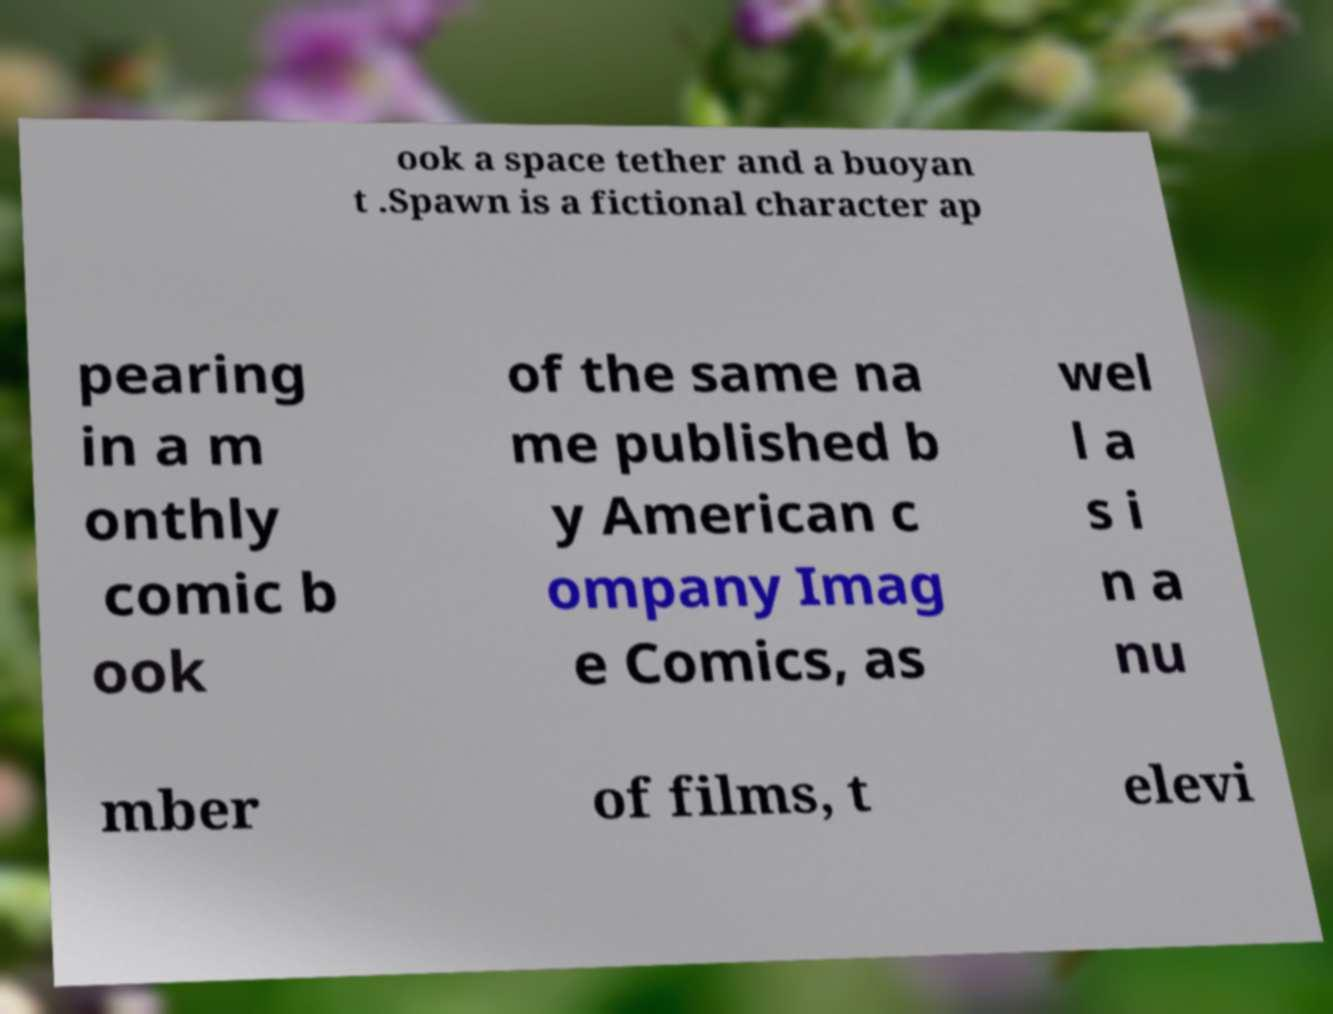Can you accurately transcribe the text from the provided image for me? ook a space tether and a buoyan t .Spawn is a fictional character ap pearing in a m onthly comic b ook of the same na me published b y American c ompany Imag e Comics, as wel l a s i n a nu mber of films, t elevi 